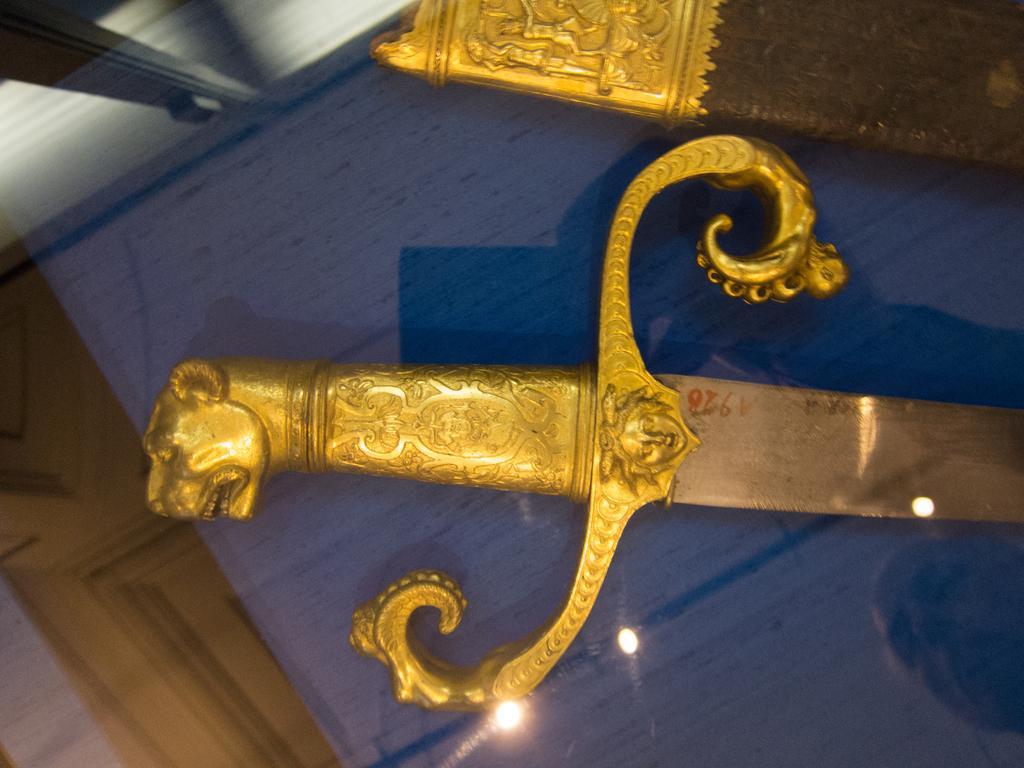Please provide a concise description of this image. In the image there is a sword inside a glass box, there is light reflection visible on the glass 